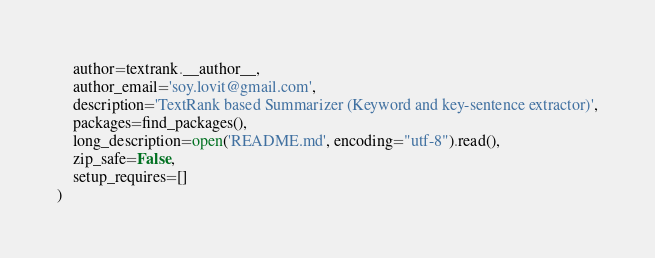<code> <loc_0><loc_0><loc_500><loc_500><_Python_>    author=textrank.__author__,
    author_email='soy.lovit@gmail.com',
    description='TextRank based Summarizer (Keyword and key-sentence extractor)',
    packages=find_packages(),
    long_description=open('README.md', encoding="utf-8").read(),
    zip_safe=False,
    setup_requires=[]
)
</code> 